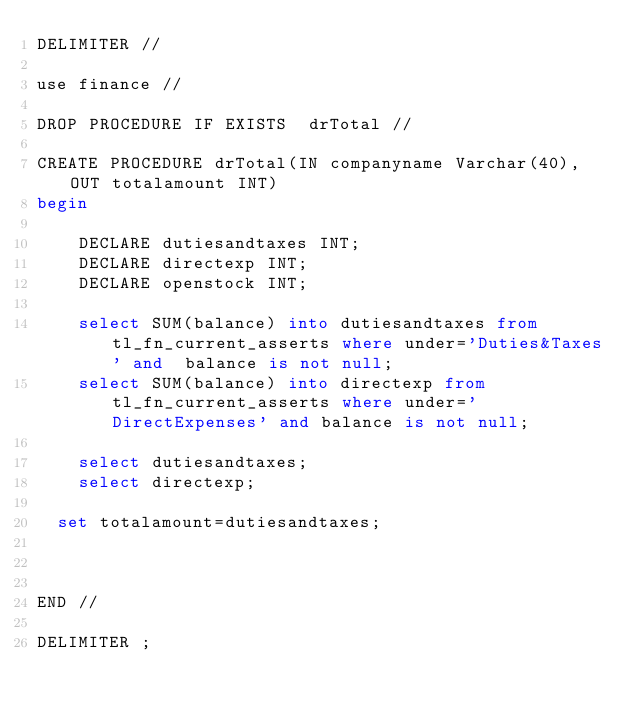<code> <loc_0><loc_0><loc_500><loc_500><_SQL_>DELIMITER //

use finance //

DROP PROCEDURE IF EXISTS  drTotal //

CREATE PROCEDURE drTotal(IN companyname Varchar(40),OUT totalamount INT)
begin
	
    DECLARE dutiesandtaxes INT;
    DECLARE directexp INT;
    DECLARE openstock INT;
	
    select SUM(balance) into dutiesandtaxes from tl_fn_current_asserts where under='Duties&Taxes' and  balance is not null;
    select SUM(balance) into directexp from tl_fn_current_asserts where under='DirectExpenses' and balance is not null;
    
    select dutiesandtaxes;
    select directexp;
    
  set totalamount=dutiesandtaxes;



END //

DELIMITER ;</code> 